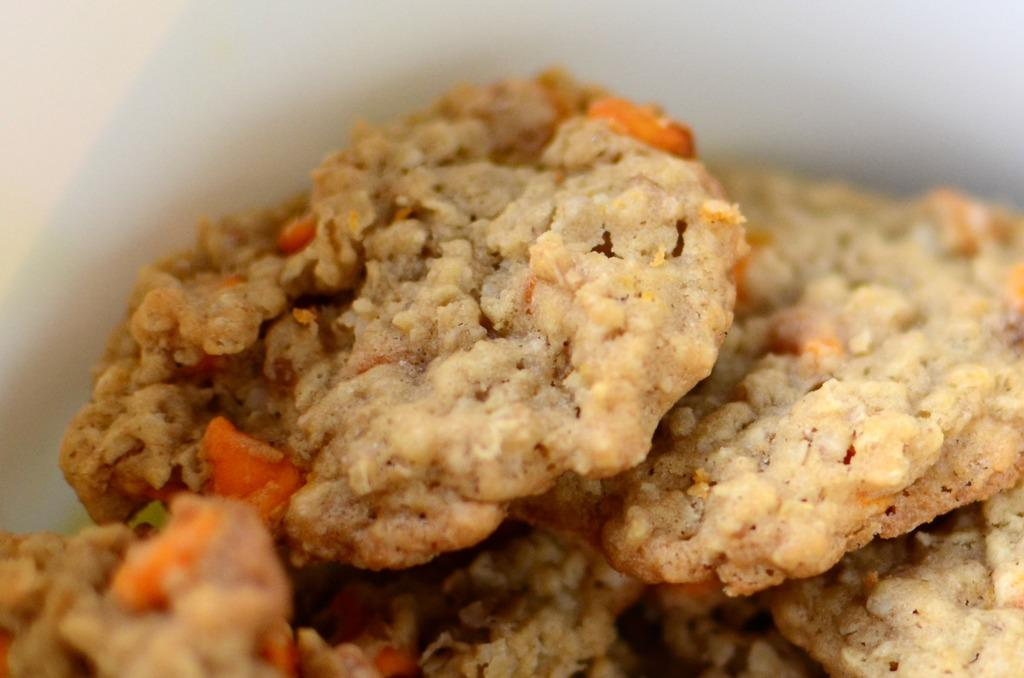What is the main subject of the image? There is a food item in the image. Can you describe the white object in the background? There is a white object in the background of the image. What type of creature is interacting with the food item in the image? There is no creature present in the image; it only features a food item and a white object in the background. How many partners are visible in the image? There is no indication of any partners in the image, as it only contains a food item and a white object in the background. 